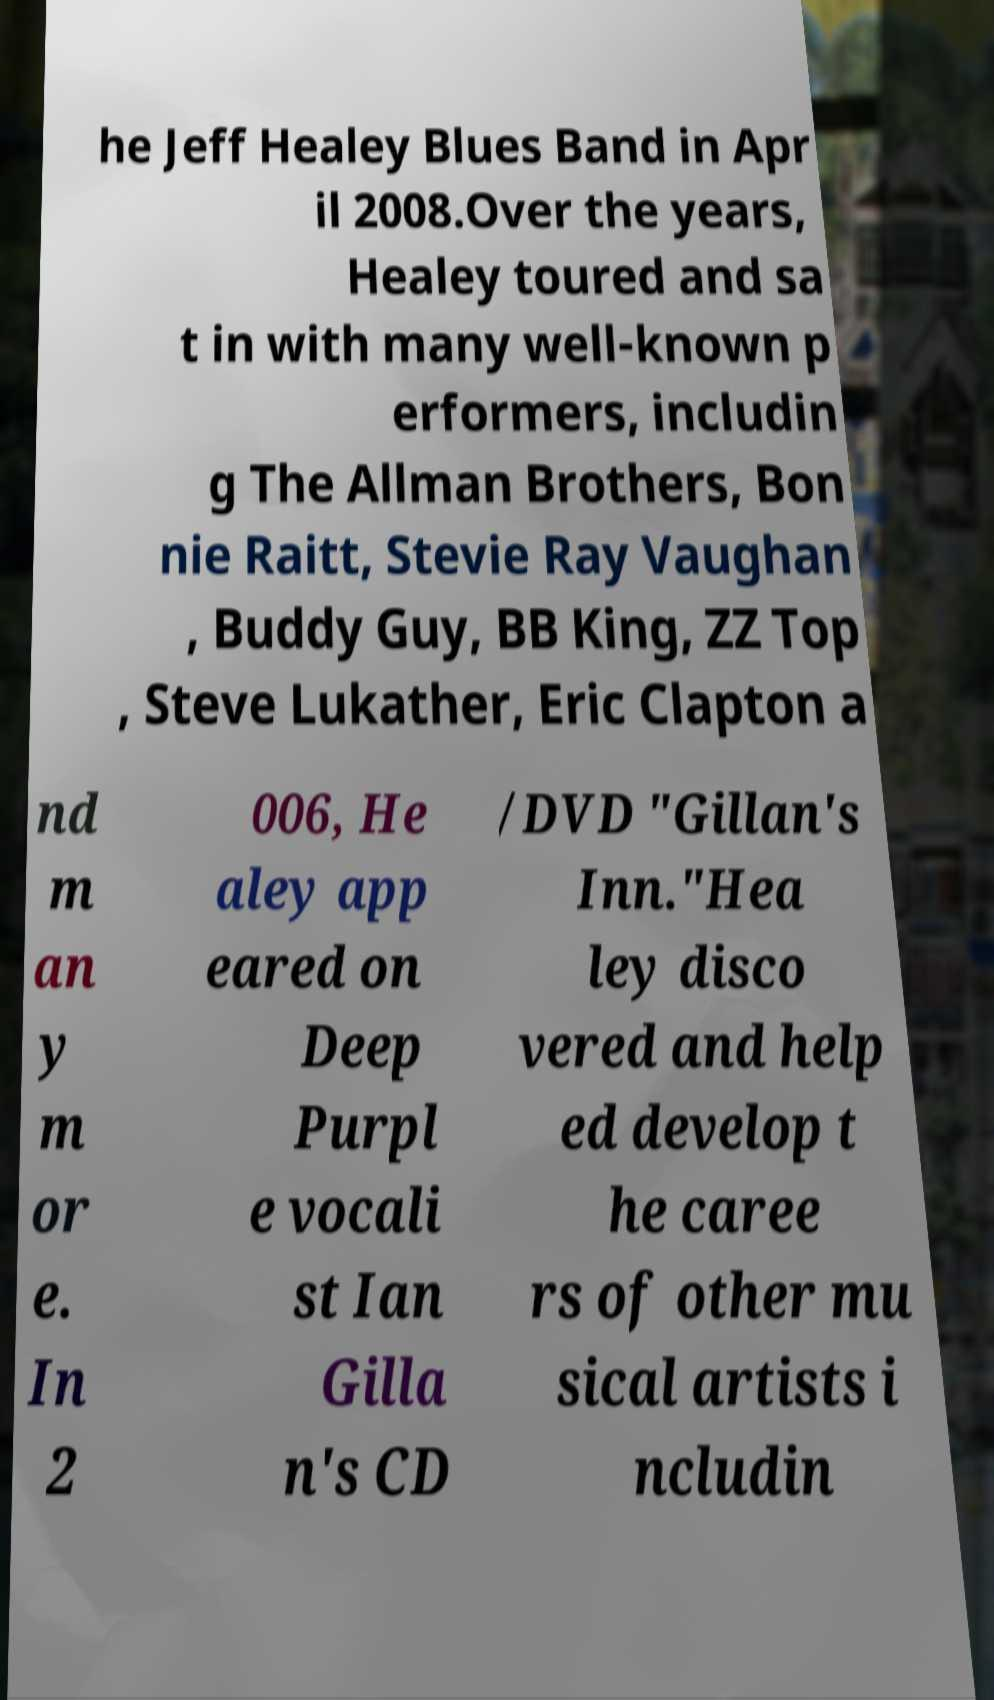Can you read and provide the text displayed in the image?This photo seems to have some interesting text. Can you extract and type it out for me? he Jeff Healey Blues Band in Apr il 2008.Over the years, Healey toured and sa t in with many well-known p erformers, includin g The Allman Brothers, Bon nie Raitt, Stevie Ray Vaughan , Buddy Guy, BB King, ZZ Top , Steve Lukather, Eric Clapton a nd m an y m or e. In 2 006, He aley app eared on Deep Purpl e vocali st Ian Gilla n's CD /DVD "Gillan's Inn."Hea ley disco vered and help ed develop t he caree rs of other mu sical artists i ncludin 